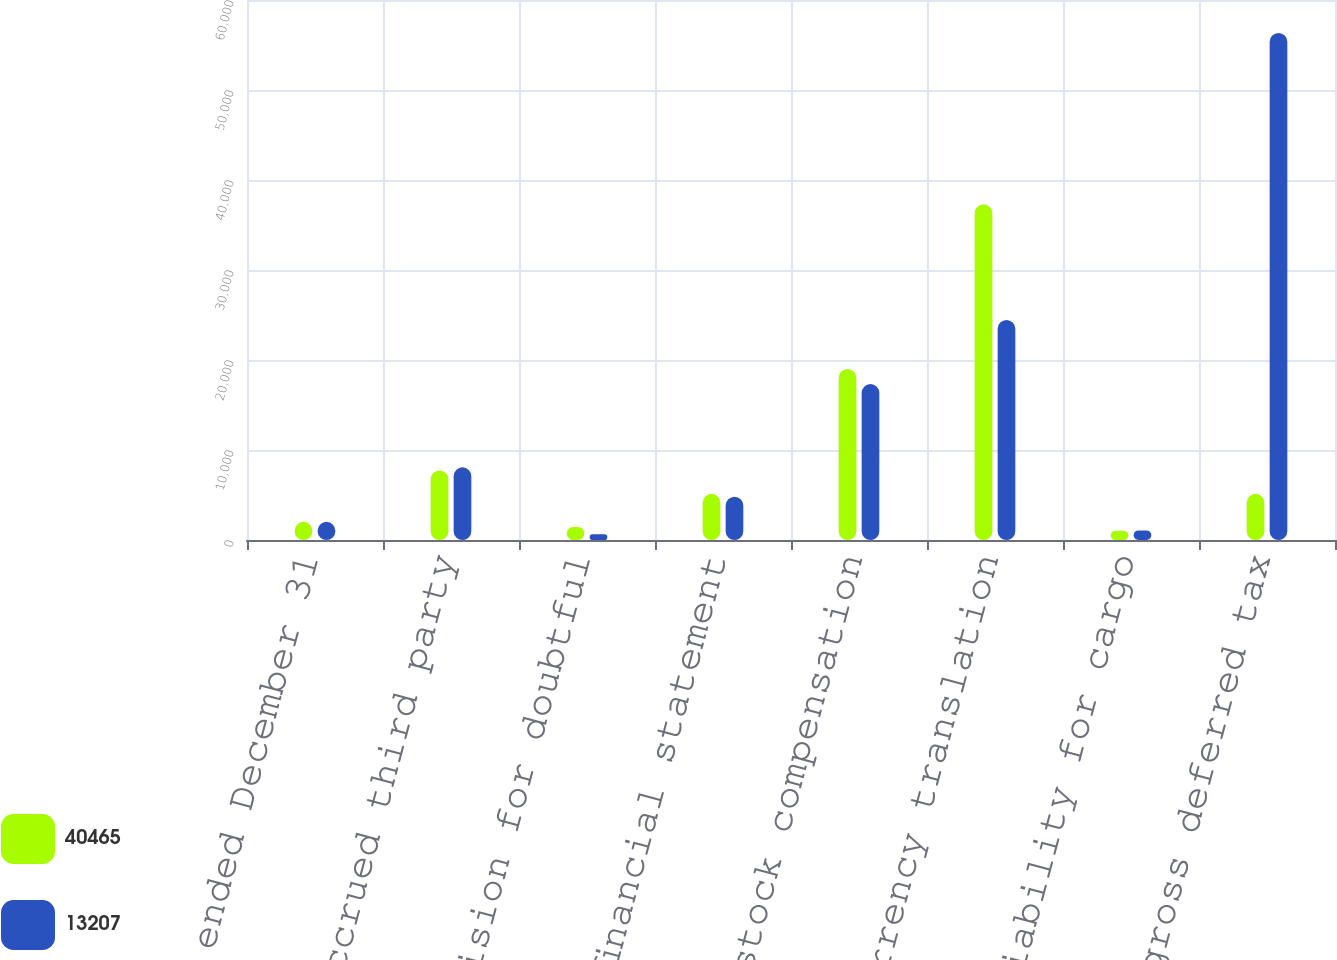Convert chart. <chart><loc_0><loc_0><loc_500><loc_500><stacked_bar_chart><ecel><fcel>Years ended December 31<fcel>Accrued third party<fcel>Provision for doubtful<fcel>Excess of financial statement<fcel>Deductible stock compensation<fcel>Foreign currency translation<fcel>Retained liability for cargo<fcel>Total gross deferred tax<nl><fcel>40465<fcel>2018<fcel>7726<fcel>1443<fcel>5134<fcel>19011<fcel>37299<fcel>1025<fcel>5134<nl><fcel>13207<fcel>2017<fcel>8075<fcel>628<fcel>4804<fcel>17326<fcel>24448<fcel>1062<fcel>56343<nl></chart> 